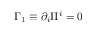<formula> <loc_0><loc_0><loc_500><loc_500>{ \Gamma _ { 1 } } \equiv \partial _ { i } { \Pi ^ { i } } = 0</formula> 